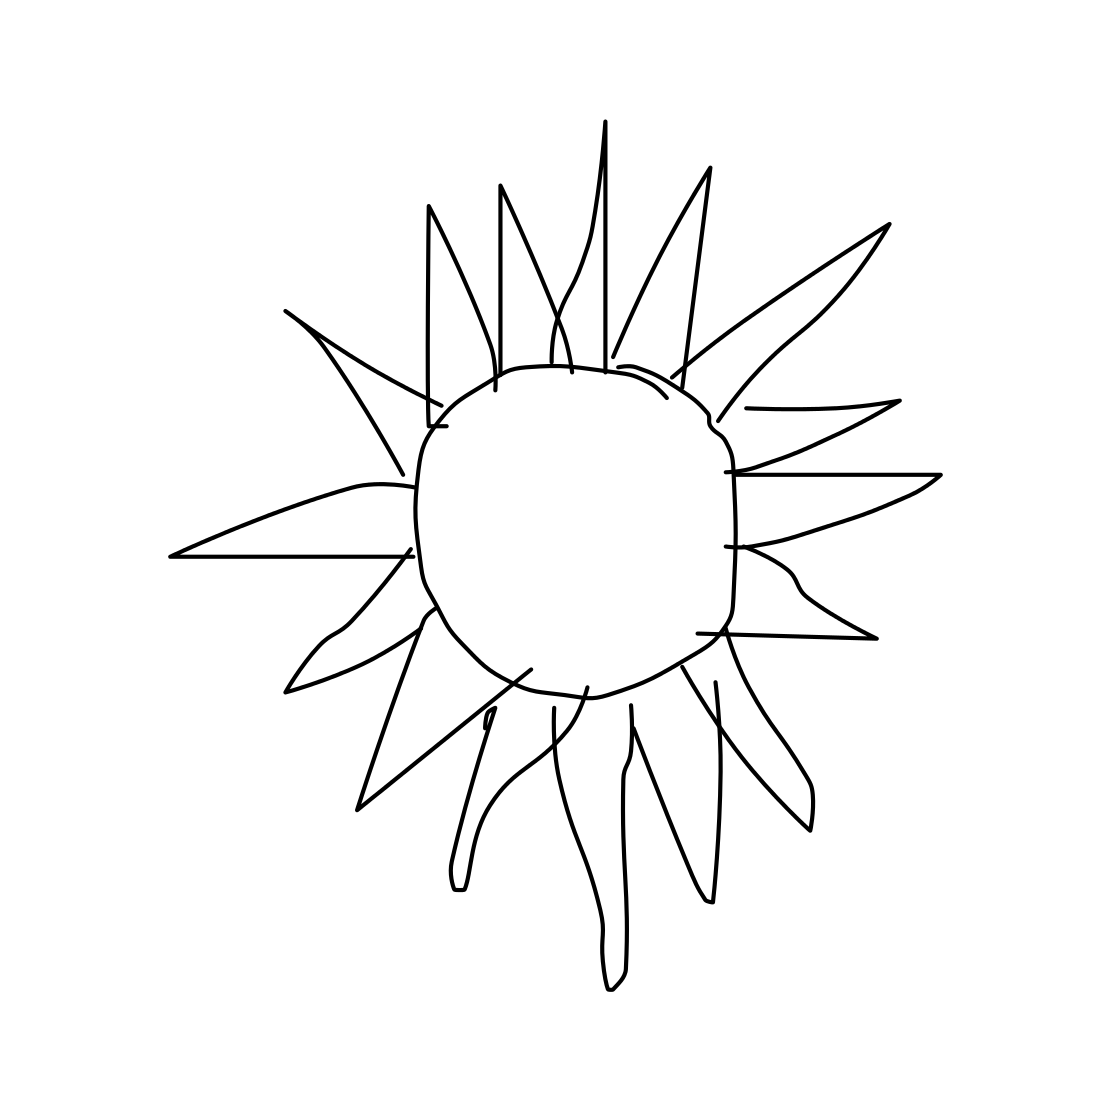How would you interpret the rays of the sun in this image? The rays appear irregular in length and spacing, suggesting a more hand-drawn, organic approach. This could reflect uniqueness or diversity, implying that like the sun's rays, no two things are exactly alike. 